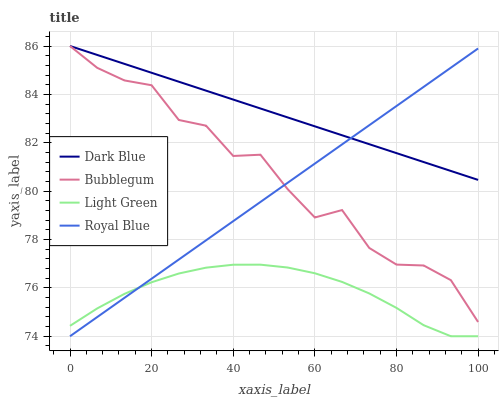Does Light Green have the minimum area under the curve?
Answer yes or no. Yes. Does Dark Blue have the maximum area under the curve?
Answer yes or no. Yes. Does Bubblegum have the minimum area under the curve?
Answer yes or no. No. Does Bubblegum have the maximum area under the curve?
Answer yes or no. No. Is Royal Blue the smoothest?
Answer yes or no. Yes. Is Bubblegum the roughest?
Answer yes or no. Yes. Is Light Green the smoothest?
Answer yes or no. No. Is Light Green the roughest?
Answer yes or no. No. Does Light Green have the lowest value?
Answer yes or no. Yes. Does Bubblegum have the lowest value?
Answer yes or no. No. Does Bubblegum have the highest value?
Answer yes or no. Yes. Does Light Green have the highest value?
Answer yes or no. No. Is Light Green less than Dark Blue?
Answer yes or no. Yes. Is Dark Blue greater than Light Green?
Answer yes or no. Yes. Does Bubblegum intersect Royal Blue?
Answer yes or no. Yes. Is Bubblegum less than Royal Blue?
Answer yes or no. No. Is Bubblegum greater than Royal Blue?
Answer yes or no. No. Does Light Green intersect Dark Blue?
Answer yes or no. No. 